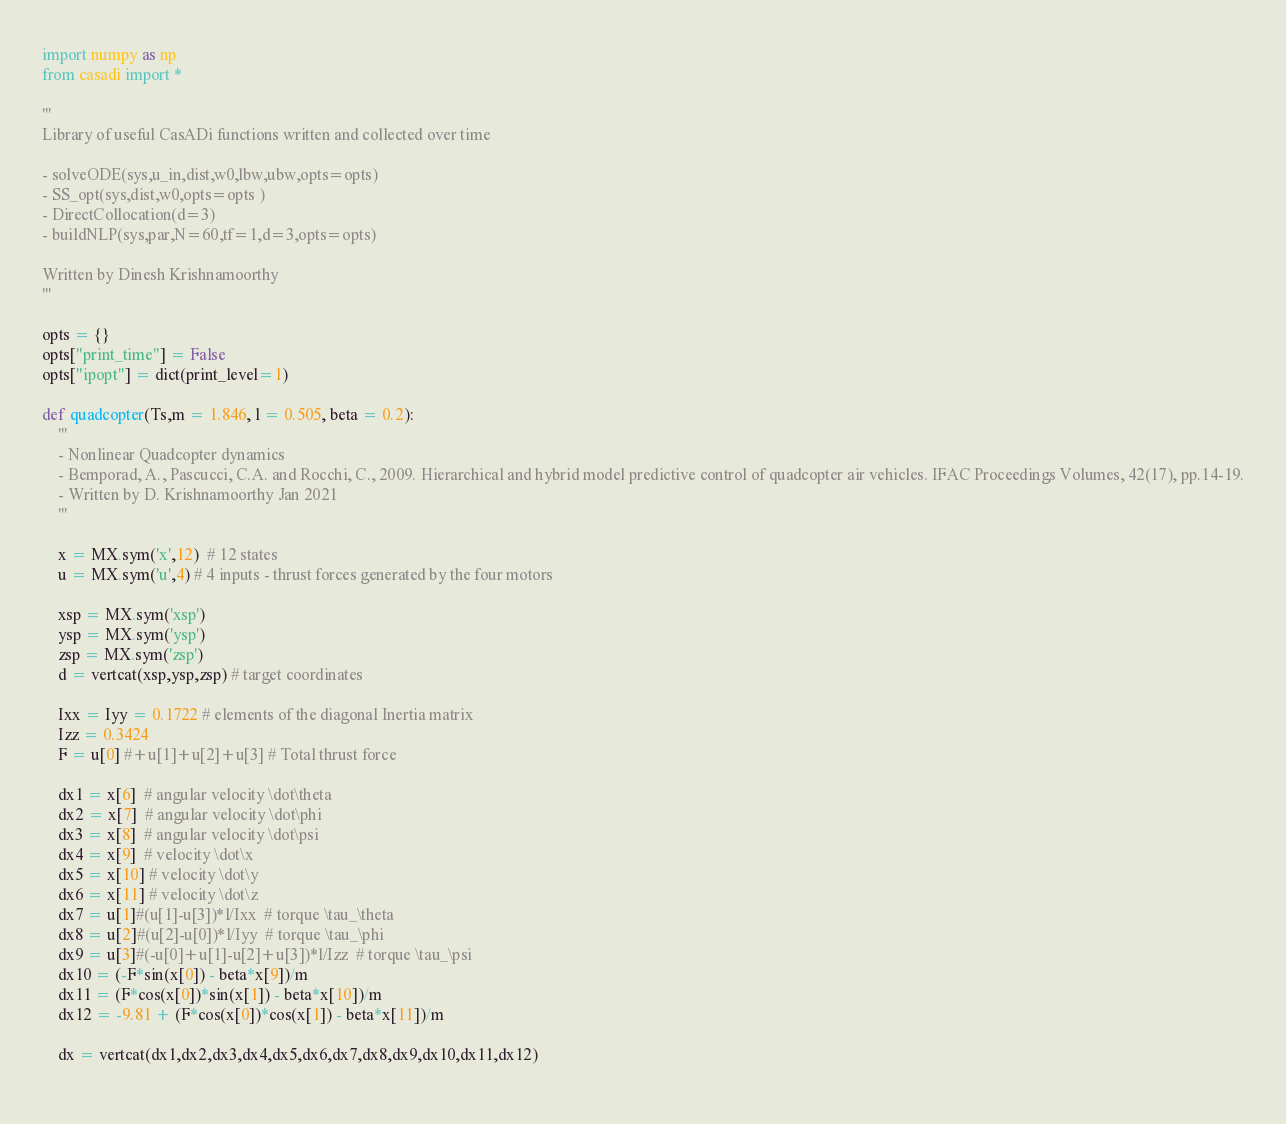<code> <loc_0><loc_0><loc_500><loc_500><_Python_>import numpy as np
from casadi import *

'''
Library of useful CasADi functions written and collected over time

- solveODE(sys,u_in,dist,w0,lbw,ubw,opts=opts)
- SS_opt(sys,dist,w0,opts=opts )
- DirectCollocation(d=3)
- buildNLP(sys,par,N=60,tf=1,d=3,opts=opts)

Written by Dinesh Krishnamoorthy
'''

opts = {}
opts["print_time"] = False
opts["ipopt"] = dict(print_level=1)

def quadcopter(Ts,m = 1.846, l = 0.505, beta = 0.2):
    '''
    - Nonlinear Quadcopter dynamics
    - Bemporad, A., Pascucci, C.A. and Rocchi, C., 2009. Hierarchical and hybrid model predictive control of quadcopter air vehicles. IFAC Proceedings Volumes, 42(17), pp.14-19.
    - Written by D. Krishnamoorthy Jan 2021
    '''

    x = MX.sym('x',12)  # 12 states
    u = MX.sym('u',4) # 4 inputs - thrust forces generated by the four motors
    
    xsp = MX.sym('xsp')
    ysp = MX.sym('ysp')
    zsp = MX.sym('zsp')
    d = vertcat(xsp,ysp,zsp) # target coordinates

    Ixx = Iyy = 0.1722 # elements of the diagonal Inertia matrix
    Izz = 0.3424 
    F = u[0] #+u[1]+u[2]+u[3] # Total thrust force

    dx1 = x[6]  # angular velocity \dot\theta
    dx2 = x[7]  # angular velocity \dot\phi
    dx3 = x[8]  # angular velocity \dot\psi
    dx4 = x[9]  # velocity \dot\x
    dx5 = x[10] # velocity \dot\y
    dx6 = x[11] # velocity \dot\z
    dx7 = u[1]#(u[1]-u[3])*l/Ixx  # torque \tau_\theta
    dx8 = u[2]#(u[2]-u[0])*l/Iyy  # torque \tau_\phi
    dx9 = u[3]#(-u[0]+u[1]-u[2]+u[3])*l/Izz  # torque \tau_\psi
    dx10 = (-F*sin(x[0]) - beta*x[9])/m
    dx11 = (F*cos(x[0])*sin(x[1]) - beta*x[10])/m
    dx12 = -9.81 + (F*cos(x[0])*cos(x[1]) - beta*x[11])/m

    dx = vertcat(dx1,dx2,dx3,dx4,dx5,dx6,dx7,dx8,dx9,dx10,dx11,dx12)
    </code> 